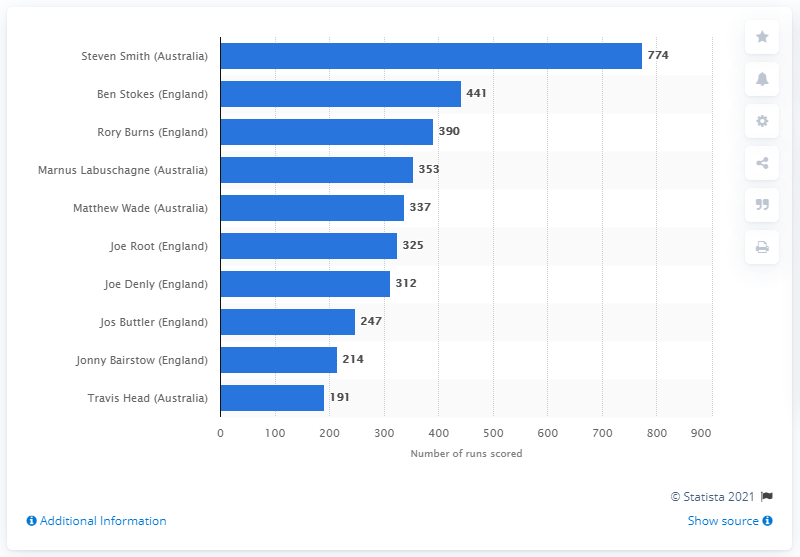Mention a couple of crucial points in this snapshot. Steve Smith scored 774 runs in seven innings. 